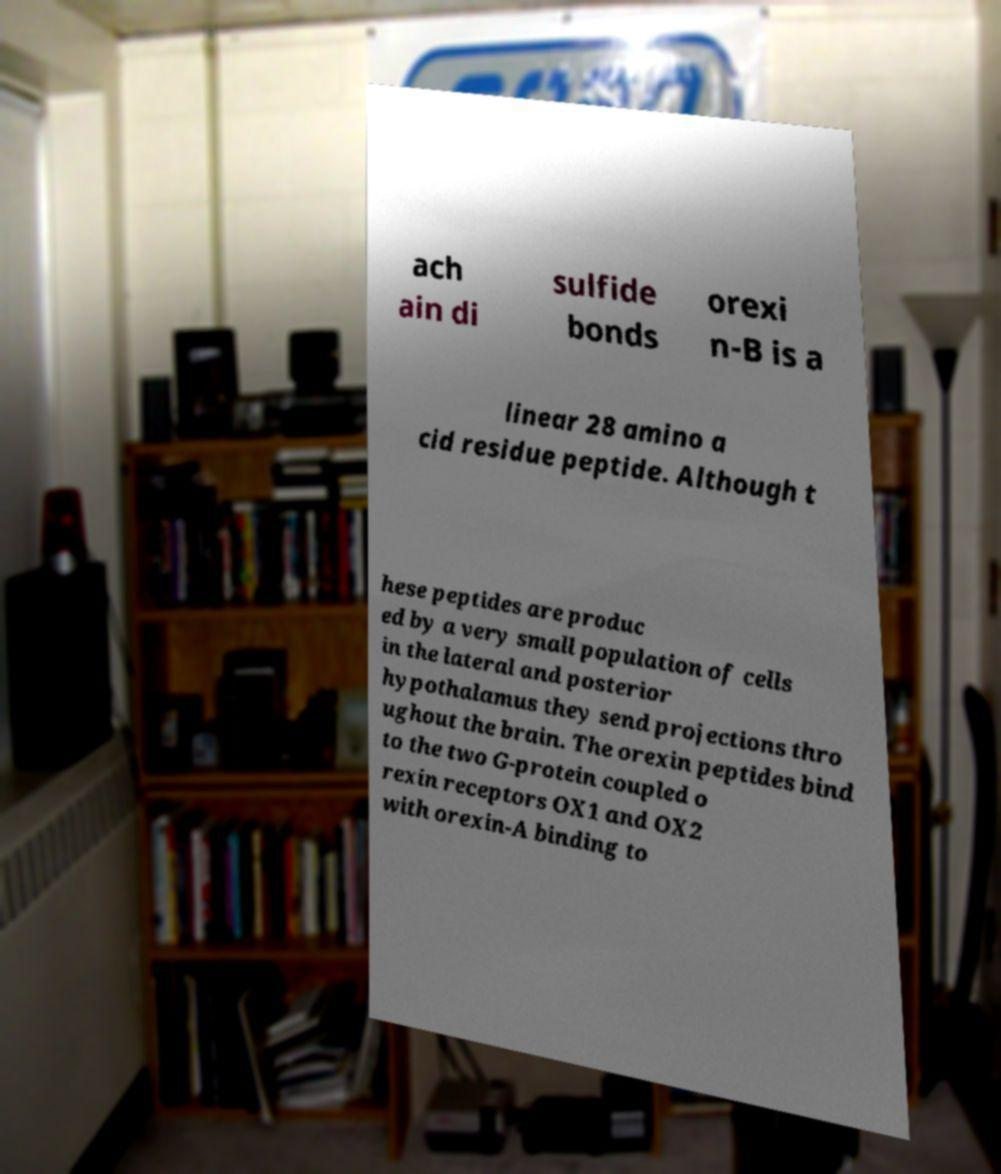Could you extract and type out the text from this image? ach ain di sulfide bonds orexi n-B is a linear 28 amino a cid residue peptide. Although t hese peptides are produc ed by a very small population of cells in the lateral and posterior hypothalamus they send projections thro ughout the brain. The orexin peptides bind to the two G-protein coupled o rexin receptors OX1 and OX2 with orexin-A binding to 